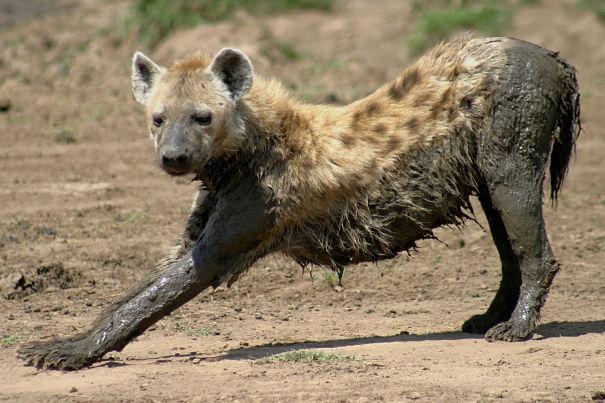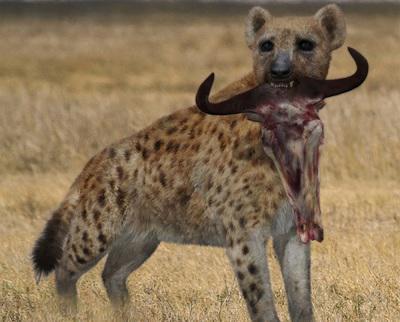The first image is the image on the left, the second image is the image on the right. For the images displayed, is the sentence "One image contains at a least two hyenas." factually correct? Answer yes or no. No. 